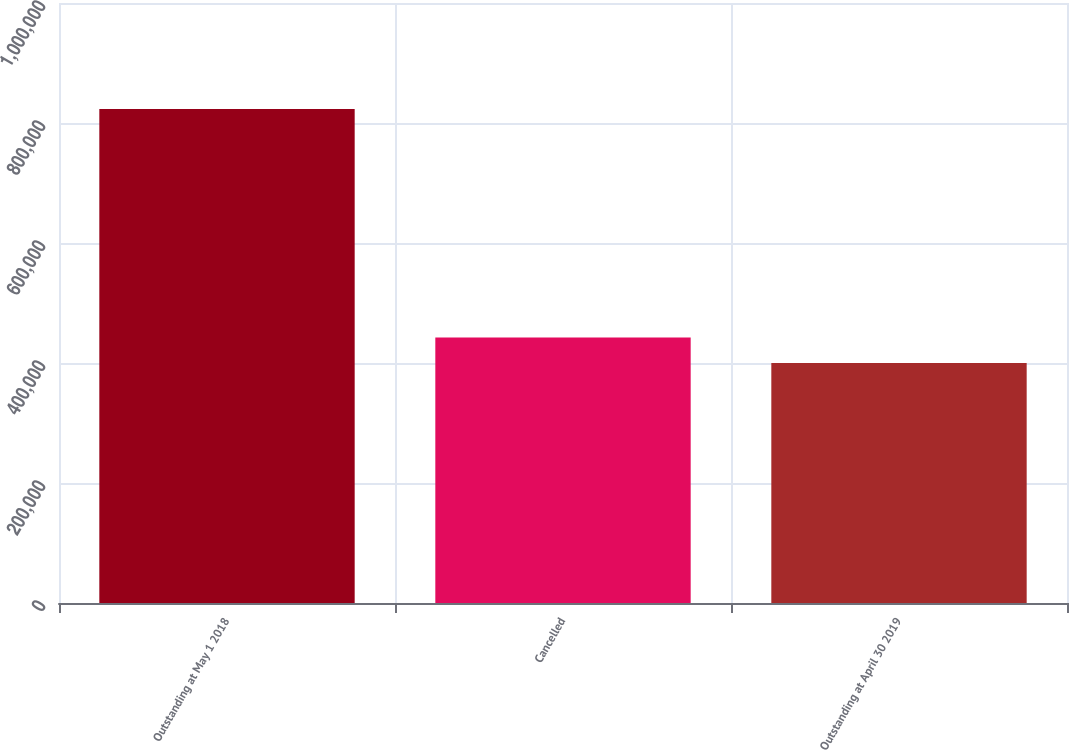<chart> <loc_0><loc_0><loc_500><loc_500><bar_chart><fcel>Outstanding at May 1 2018<fcel>Cancelled<fcel>Outstanding at April 30 2019<nl><fcel>823332<fcel>442333<fcel>400000<nl></chart> 